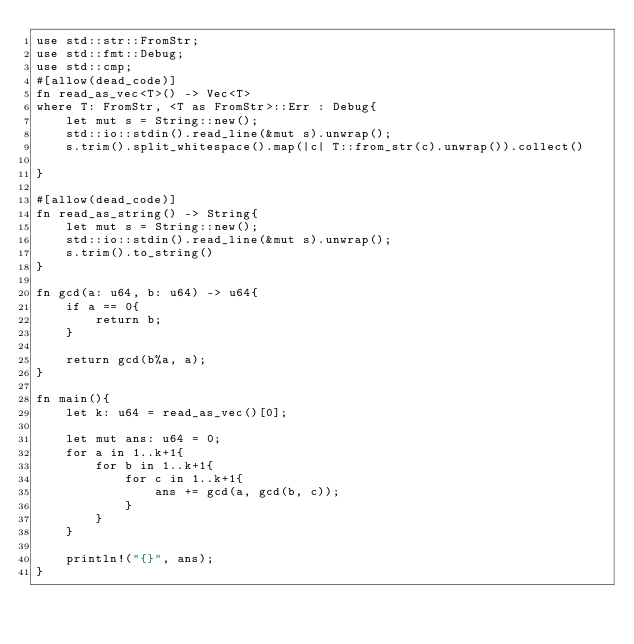Convert code to text. <code><loc_0><loc_0><loc_500><loc_500><_Rust_>use std::str::FromStr;
use std::fmt::Debug;
use std::cmp;
#[allow(dead_code)]
fn read_as_vec<T>() -> Vec<T>
where T: FromStr, <T as FromStr>::Err : Debug{
    let mut s = String::new();
    std::io::stdin().read_line(&mut s).unwrap();
    s.trim().split_whitespace().map(|c| T::from_str(c).unwrap()).collect()

}

#[allow(dead_code)]
fn read_as_string() -> String{
    let mut s = String::new();
    std::io::stdin().read_line(&mut s).unwrap();
    s.trim().to_string()
}

fn gcd(a: u64, b: u64) -> u64{
    if a == 0{
        return b;
    }

    return gcd(b%a, a);
}

fn main(){
    let k: u64 = read_as_vec()[0];

    let mut ans: u64 = 0;
    for a in 1..k+1{
        for b in 1..k+1{
            for c in 1..k+1{
                ans += gcd(a, gcd(b, c));
            }
        }
    }

    println!("{}", ans);
}
</code> 